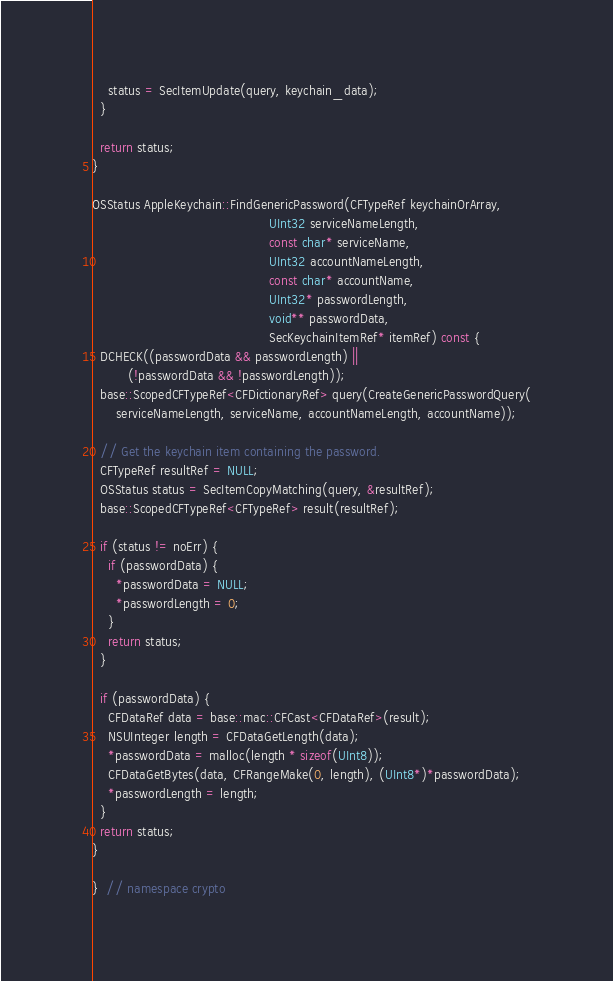<code> <loc_0><loc_0><loc_500><loc_500><_ObjectiveC_>    status = SecItemUpdate(query, keychain_data);
  }

  return status;
}

OSStatus AppleKeychain::FindGenericPassword(CFTypeRef keychainOrArray,
                                            UInt32 serviceNameLength,
                                            const char* serviceName,
                                            UInt32 accountNameLength,
                                            const char* accountName,
                                            UInt32* passwordLength,
                                            void** passwordData,
                                            SecKeychainItemRef* itemRef) const {
  DCHECK((passwordData && passwordLength) ||
         (!passwordData && !passwordLength));
  base::ScopedCFTypeRef<CFDictionaryRef> query(CreateGenericPasswordQuery(
      serviceNameLength, serviceName, accountNameLength, accountName));

  // Get the keychain item containing the password.
  CFTypeRef resultRef = NULL;
  OSStatus status = SecItemCopyMatching(query, &resultRef);
  base::ScopedCFTypeRef<CFTypeRef> result(resultRef);

  if (status != noErr) {
    if (passwordData) {
      *passwordData = NULL;
      *passwordLength = 0;
    }
    return status;
  }

  if (passwordData) {
    CFDataRef data = base::mac::CFCast<CFDataRef>(result);
    NSUInteger length = CFDataGetLength(data);
    *passwordData = malloc(length * sizeof(UInt8));
    CFDataGetBytes(data, CFRangeMake(0, length), (UInt8*)*passwordData);
    *passwordLength = length;
  }
  return status;
}

}  // namespace crypto
</code> 